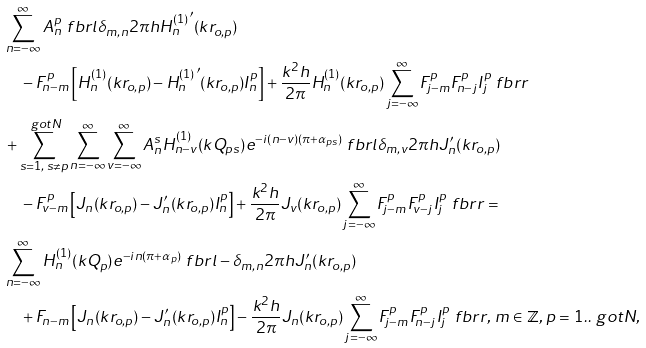<formula> <loc_0><loc_0><loc_500><loc_500>& \sum _ { n = - \infty } ^ { \infty } A _ { n } ^ { p } \ f b r l \delta _ { m , n } 2 \pi h { H _ { n } ^ { ( 1 ) } } ^ { \prime } ( k r _ { o , p } ) \\ & \quad - F _ { n - m } ^ { p } \left [ H _ { n } ^ { ( 1 ) } ( k r _ { o , p } ) - { H _ { n } ^ { ( 1 ) } } ^ { \prime } ( k r _ { o , p } ) I _ { n } ^ { p } \right ] + \frac { k ^ { 2 } h } { 2 \pi } H _ { n } ^ { ( 1 ) } ( k r _ { o , p } ) \sum _ { j = - \infty } ^ { \infty } F _ { j - m } ^ { p } F _ { n - j } ^ { p } I _ { j } ^ { p } \ f b r r \\ & + \sum _ { s = 1 , \, s \neq p } ^ { \ g o t { N } } \sum _ { n = - \infty } ^ { \infty } \sum _ { v = - \infty } ^ { \infty } A _ { n } ^ { s } H _ { n - v } ^ { ( 1 ) } ( k Q _ { p s } ) e ^ { - i ( n - v ) ( \pi + \alpha _ { p s } ) } \ f b r l \delta _ { m , v } 2 \pi h J ^ { \prime } _ { n } ( k r _ { o , p } ) \\ & \quad - F _ { v - m } ^ { p } \left [ J _ { n } ( k r _ { o , p } ) - J ^ { \prime } _ { n } ( k r _ { o , p } ) I _ { n } ^ { p } \right ] + \frac { k ^ { 2 } h } { 2 \pi } J _ { v } ( k r _ { o , p } ) \sum _ { j = - \infty } ^ { \infty } F _ { j - m } ^ { p } F _ { v - j } ^ { p } I _ { j } ^ { p } \ f b r r = \\ & \sum _ { n = - \infty } ^ { \infty } H _ { n } ^ { ( 1 ) } ( k Q _ { p } ) e ^ { - i n ( \pi + \alpha _ { p } ) } \ f b r l - \delta _ { m , n } 2 \pi h J ^ { \prime } _ { n } ( k r _ { o , p } ) \\ & \quad + F _ { n - m } \left [ J _ { n } ( k r _ { o , p } ) - J ^ { \prime } _ { n } ( k r _ { o , p } ) I _ { n } ^ { p } \right ] - \frac { k ^ { 2 } h } { 2 \pi } J _ { n } ( k r _ { o , p } ) \sum _ { j = - \infty } ^ { \infty } F _ { j - m } ^ { p } F _ { n - j } ^ { p } I _ { j } ^ { p } \ f b r r , \, m \in \mathbb { Z } , \, p = 1 . . \ g o t { N } ,</formula> 